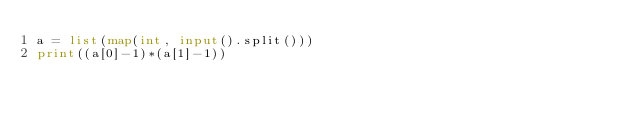Convert code to text. <code><loc_0><loc_0><loc_500><loc_500><_Python_>a = list(map(int, input().split()))
print((a[0]-1)*(a[1]-1))
</code> 